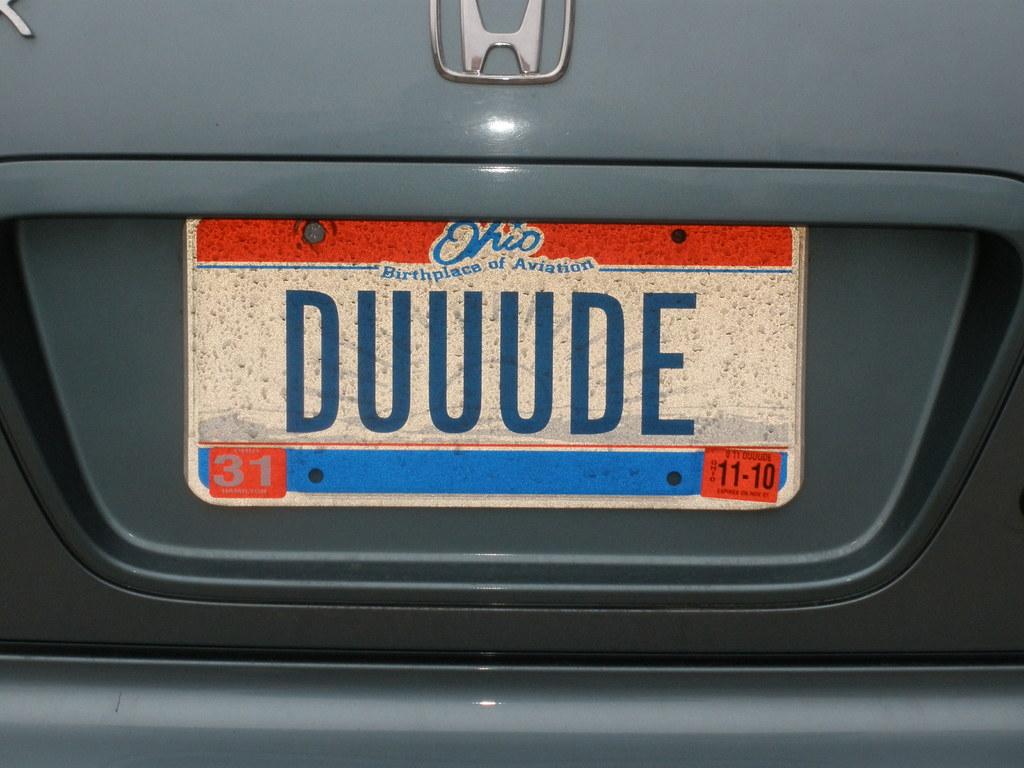What is the license plate number?
Offer a very short reply. Duuude. 